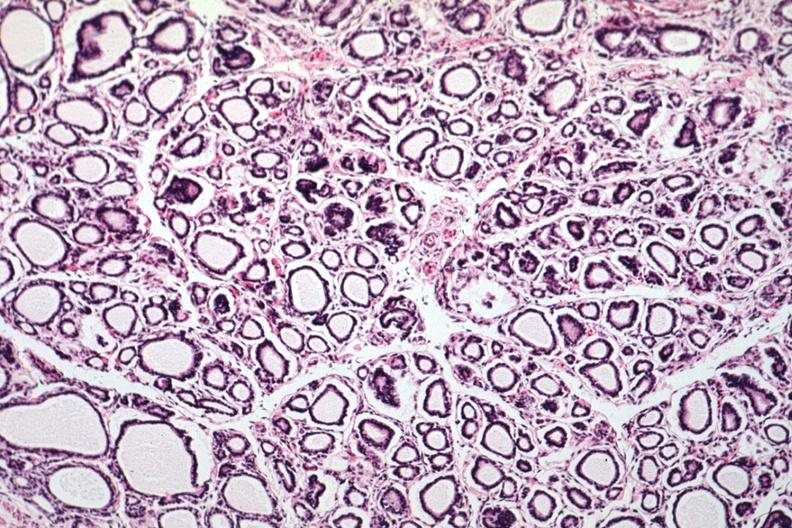what is present?
Answer the question using a single word or phrase. Thyroid 